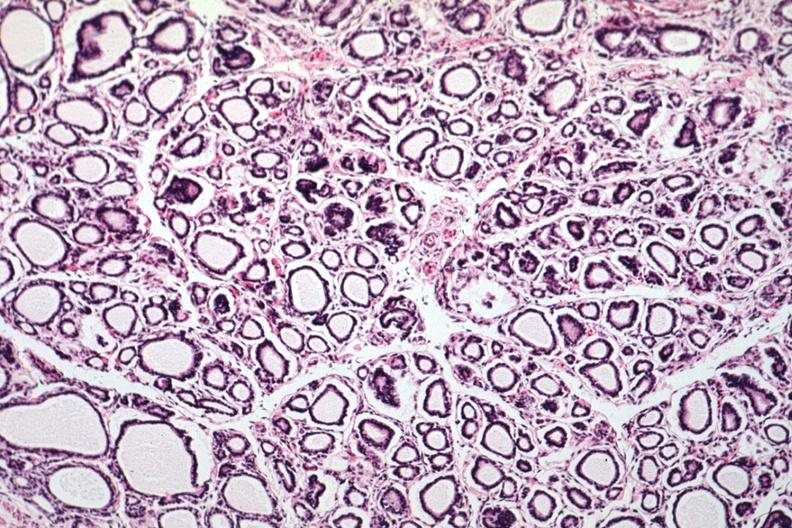what is present?
Answer the question using a single word or phrase. Thyroid 